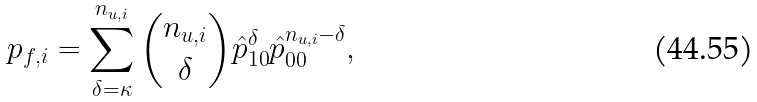<formula> <loc_0><loc_0><loc_500><loc_500>p _ { f , i } = \sum _ { \delta = \kappa } ^ { n _ { u , i } } { n _ { u , i } \choose \delta } \hat { p } _ { 1 0 } ^ { \delta } \hat { p } _ { 0 0 } ^ { n _ { u , i } - \delta } ,</formula> 